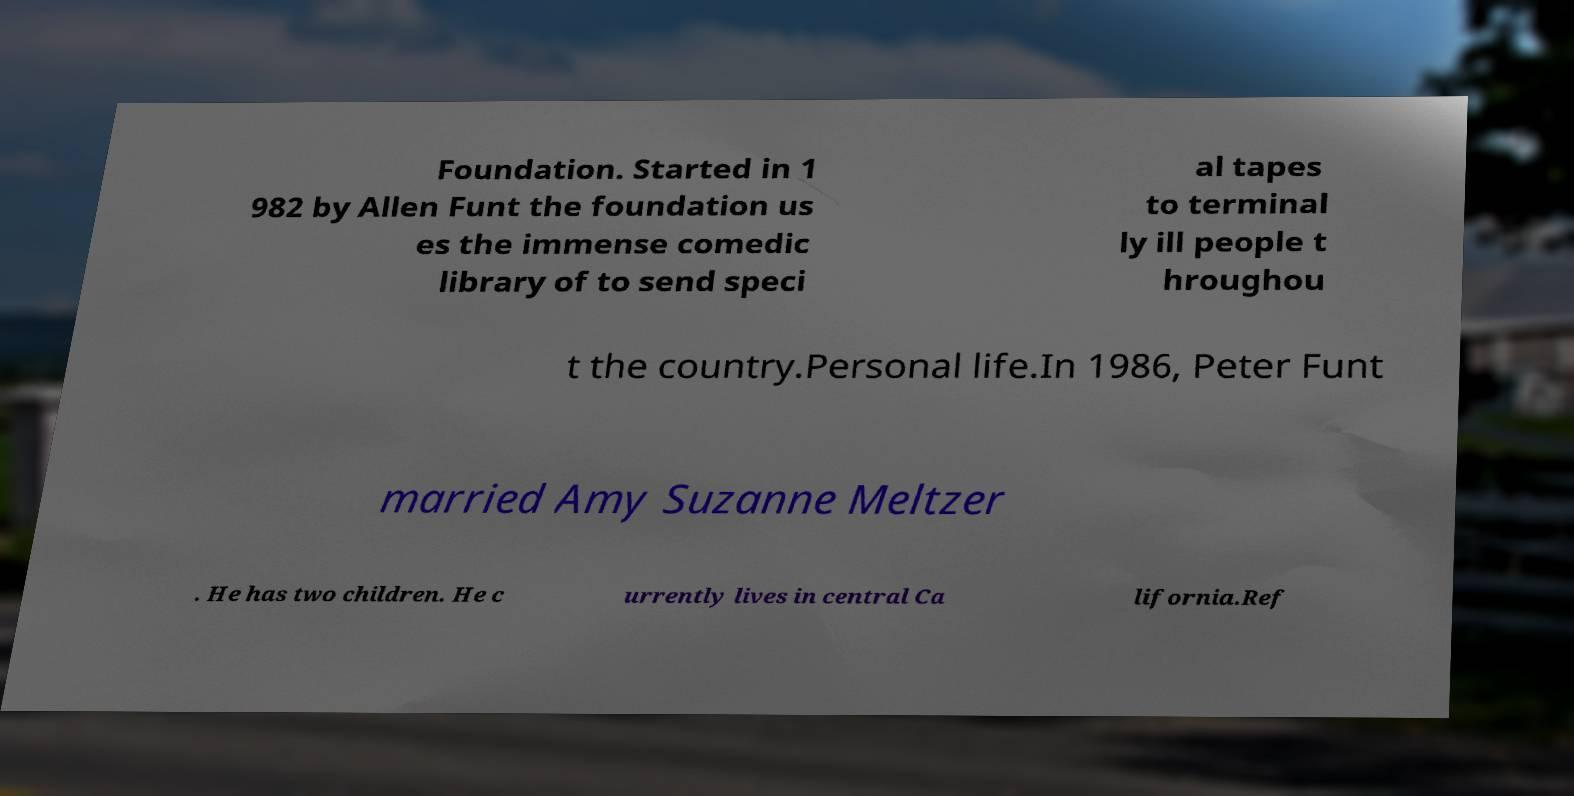Could you extract and type out the text from this image? Foundation. Started in 1 982 by Allen Funt the foundation us es the immense comedic library of to send speci al tapes to terminal ly ill people t hroughou t the country.Personal life.In 1986, Peter Funt married Amy Suzanne Meltzer . He has two children. He c urrently lives in central Ca lifornia.Ref 